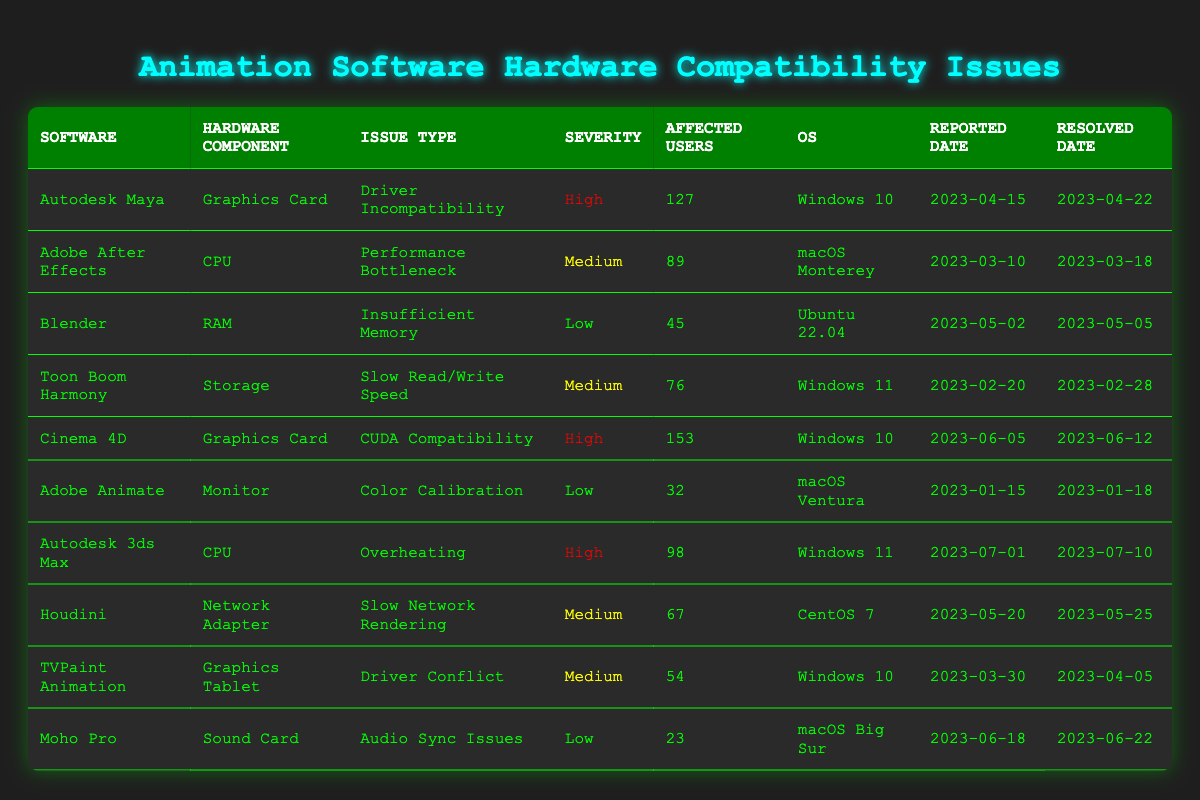What software reported the most affected users? Looking at the table, the software with the highest number of affected users is Cinema 4D, which reported 153 affected users.
Answer: Cinema 4D Which issue type was most commonly reported across all software packages? Observing the table, the issue types "Driver Incompatibility" and "Overheating" each appear once, but "Slow Read/Write Speed," "Performance Bottleneck," and "Driver Conflict" also appear once. Therefore, there isn't a single most common issue type.
Answer: No single most common issue type What is the average number of affected users for issues categorized as 'High' severity? The reported affected users for 'High' severity issues are 127 (Autodesk Maya), 153 (Cinema 4D), and 98 (Autodesk 3ds Max). Summing these values gives 378, and dividing by 3 (the number of instances) gives an average of 126.
Answer: 126 Is there any software that had an issue with a Graphics Card and was categorized as 'Medium' severity? Checking the table, the only software with a 'Graphics Card' issue is Autodesk Maya and Cinema 4D (High severity). Thus, there are no 'Medium' severity issues related to Graphics Cards.
Answer: No What was the severity of the issue reported by Adobe Animate? The issue reported by Adobe Animate was categorized as 'Low' severity related to the monitor's color calibration as stated in the table.
Answer: Low How many unique operating systems are listed in the table? The operating systems are Windows 10, macOS Monterey, Ubuntu 22.04, Windows 11, macOS Ventura, CentOS 7, and macOS Big Sur, giving a total of 6 unique operating systems.
Answer: 6 What is the difference in the number of affected users between the software with the highest users and the software with the lowest users? The software with the highest affected users is Cinema 4D (153 users) and the lowest is Moho Pro (23 users). The difference is 153 - 23 = 130.
Answer: 130 Which issue type was reported last in terms of resolved date? Looking at the resolved dates in the table, the last issue resolved was for Autodesk 3ds Max on 2023-07-10. This means that "Overheating" is the most recent issue reported.
Answer: Overheating 